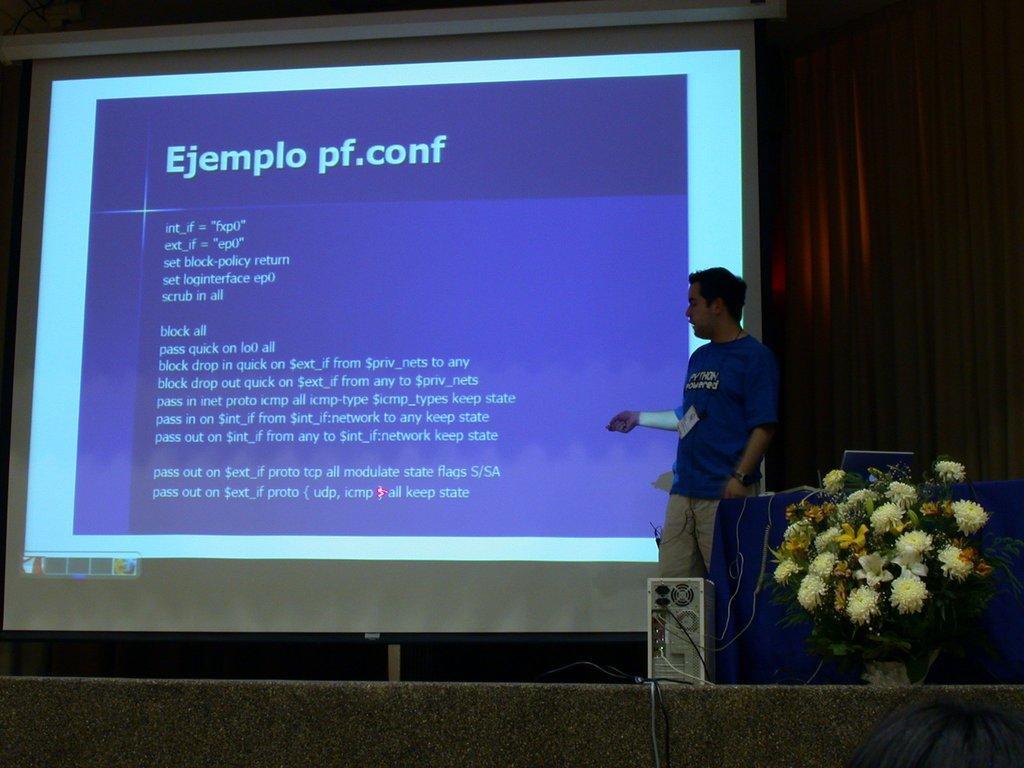How would you summarize this image in a sentence or two? In this image, on the right side, we can see a man standing. We can see a flower bouquet and a CPU. We can see the projector screen and a curtain. 